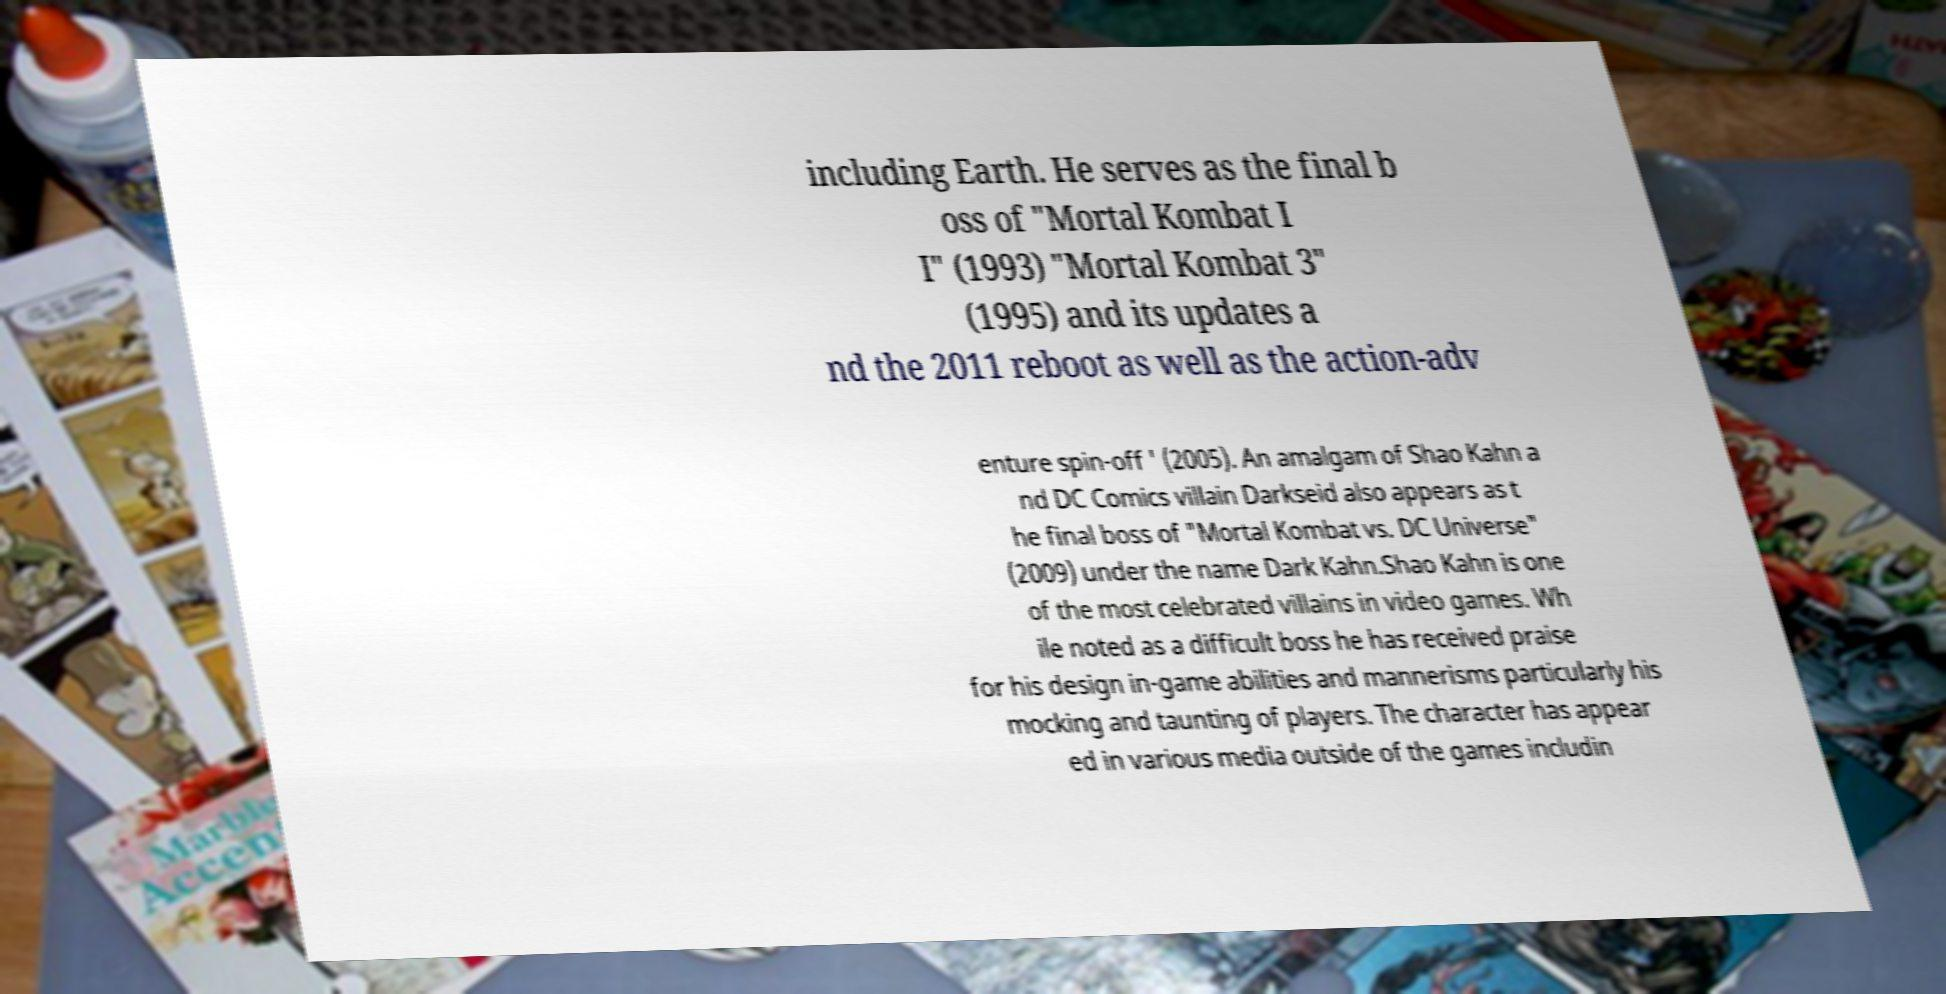I need the written content from this picture converted into text. Can you do that? including Earth. He serves as the final b oss of "Mortal Kombat I I" (1993) "Mortal Kombat 3" (1995) and its updates a nd the 2011 reboot as well as the action-adv enture spin-off ' (2005). An amalgam of Shao Kahn a nd DC Comics villain Darkseid also appears as t he final boss of "Mortal Kombat vs. DC Universe" (2009) under the name Dark Kahn.Shao Kahn is one of the most celebrated villains in video games. Wh ile noted as a difficult boss he has received praise for his design in-game abilities and mannerisms particularly his mocking and taunting of players. The character has appear ed in various media outside of the games includin 